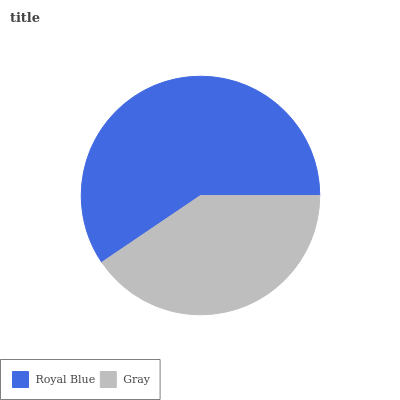Is Gray the minimum?
Answer yes or no. Yes. Is Royal Blue the maximum?
Answer yes or no. Yes. Is Gray the maximum?
Answer yes or no. No. Is Royal Blue greater than Gray?
Answer yes or no. Yes. Is Gray less than Royal Blue?
Answer yes or no. Yes. Is Gray greater than Royal Blue?
Answer yes or no. No. Is Royal Blue less than Gray?
Answer yes or no. No. Is Royal Blue the high median?
Answer yes or no. Yes. Is Gray the low median?
Answer yes or no. Yes. Is Gray the high median?
Answer yes or no. No. Is Royal Blue the low median?
Answer yes or no. No. 